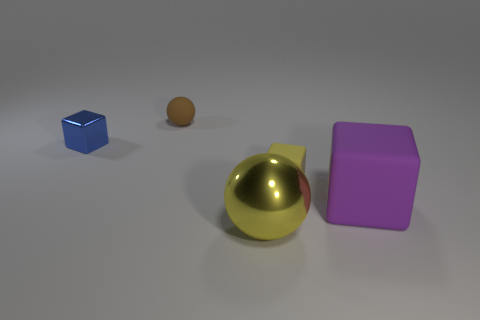Subtract all big purple blocks. How many blocks are left? 2 Add 3 small yellow blocks. How many objects exist? 8 Subtract all yellow blocks. How many blocks are left? 2 Subtract all gray cylinders. How many yellow balls are left? 1 Subtract all balls. How many objects are left? 3 Subtract 2 blocks. How many blocks are left? 1 Subtract all gray balls. Subtract all purple cylinders. How many balls are left? 2 Subtract all yellow matte things. Subtract all balls. How many objects are left? 2 Add 1 purple objects. How many purple objects are left? 2 Add 5 tiny brown matte spheres. How many tiny brown matte spheres exist? 6 